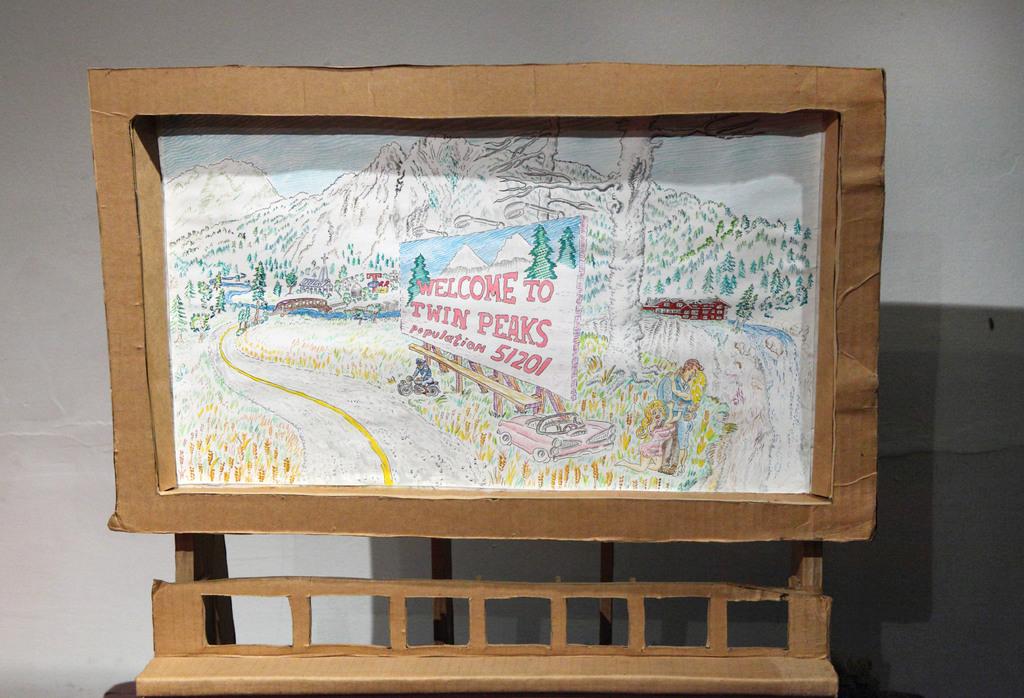What is the name of the town?
Your response must be concise. Twin peaks. 